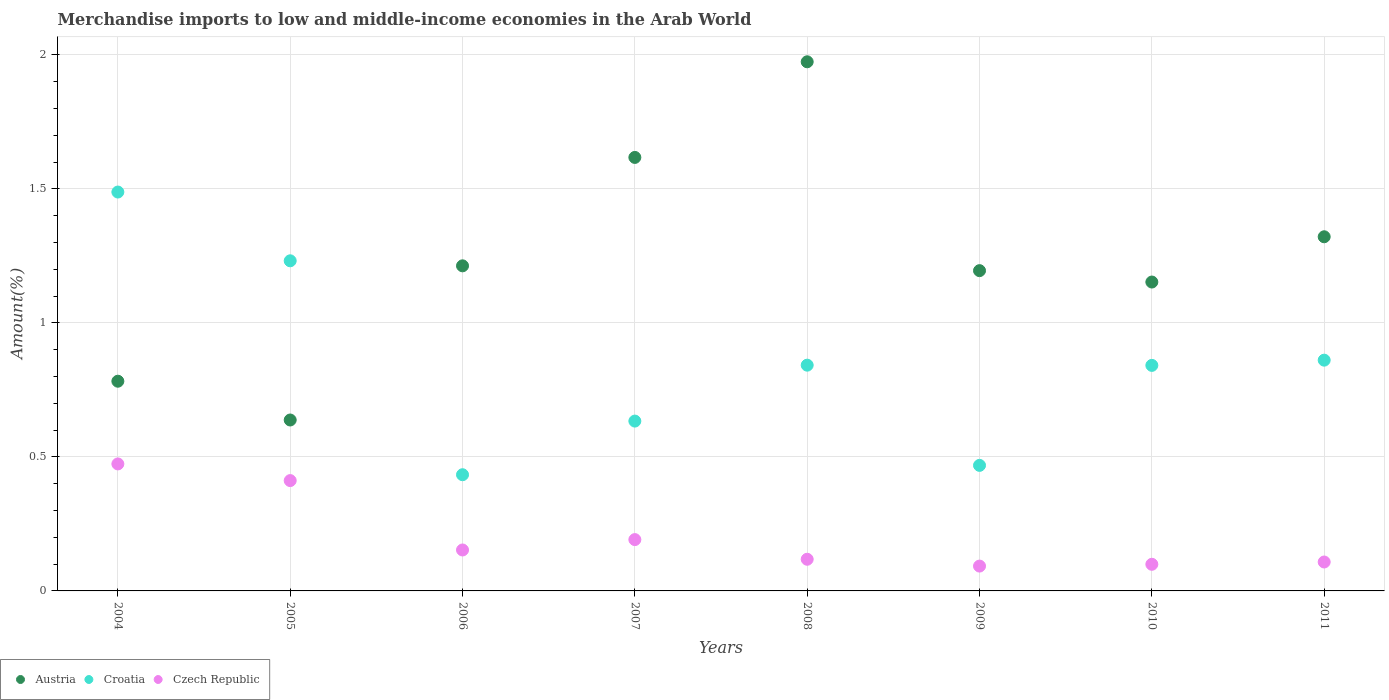How many different coloured dotlines are there?
Give a very brief answer. 3. What is the percentage of amount earned from merchandise imports in Czech Republic in 2004?
Provide a succinct answer. 0.47. Across all years, what is the maximum percentage of amount earned from merchandise imports in Croatia?
Ensure brevity in your answer.  1.49. Across all years, what is the minimum percentage of amount earned from merchandise imports in Austria?
Your answer should be very brief. 0.64. What is the total percentage of amount earned from merchandise imports in Austria in the graph?
Give a very brief answer. 9.89. What is the difference between the percentage of amount earned from merchandise imports in Austria in 2005 and that in 2006?
Provide a short and direct response. -0.58. What is the difference between the percentage of amount earned from merchandise imports in Croatia in 2004 and the percentage of amount earned from merchandise imports in Austria in 2010?
Make the answer very short. 0.34. What is the average percentage of amount earned from merchandise imports in Austria per year?
Give a very brief answer. 1.24. In the year 2011, what is the difference between the percentage of amount earned from merchandise imports in Czech Republic and percentage of amount earned from merchandise imports in Croatia?
Keep it short and to the point. -0.75. What is the ratio of the percentage of amount earned from merchandise imports in Czech Republic in 2009 to that in 2011?
Offer a terse response. 0.86. Is the percentage of amount earned from merchandise imports in Croatia in 2005 less than that in 2007?
Keep it short and to the point. No. What is the difference between the highest and the second highest percentage of amount earned from merchandise imports in Czech Republic?
Give a very brief answer. 0.06. What is the difference between the highest and the lowest percentage of amount earned from merchandise imports in Czech Republic?
Give a very brief answer. 0.38. Is it the case that in every year, the sum of the percentage of amount earned from merchandise imports in Croatia and percentage of amount earned from merchandise imports in Austria  is greater than the percentage of amount earned from merchandise imports in Czech Republic?
Provide a short and direct response. Yes. How many dotlines are there?
Keep it short and to the point. 3. How many years are there in the graph?
Offer a terse response. 8. What is the difference between two consecutive major ticks on the Y-axis?
Ensure brevity in your answer.  0.5. Does the graph contain grids?
Your response must be concise. Yes. How are the legend labels stacked?
Make the answer very short. Horizontal. What is the title of the graph?
Your response must be concise. Merchandise imports to low and middle-income economies in the Arab World. What is the label or title of the X-axis?
Keep it short and to the point. Years. What is the label or title of the Y-axis?
Offer a very short reply. Amount(%). What is the Amount(%) of Austria in 2004?
Offer a terse response. 0.78. What is the Amount(%) in Croatia in 2004?
Give a very brief answer. 1.49. What is the Amount(%) in Czech Republic in 2004?
Provide a short and direct response. 0.47. What is the Amount(%) of Austria in 2005?
Give a very brief answer. 0.64. What is the Amount(%) in Croatia in 2005?
Your response must be concise. 1.23. What is the Amount(%) of Czech Republic in 2005?
Provide a succinct answer. 0.41. What is the Amount(%) in Austria in 2006?
Provide a short and direct response. 1.21. What is the Amount(%) in Croatia in 2006?
Give a very brief answer. 0.43. What is the Amount(%) of Czech Republic in 2006?
Provide a succinct answer. 0.15. What is the Amount(%) of Austria in 2007?
Ensure brevity in your answer.  1.62. What is the Amount(%) of Croatia in 2007?
Ensure brevity in your answer.  0.63. What is the Amount(%) in Czech Republic in 2007?
Provide a short and direct response. 0.19. What is the Amount(%) of Austria in 2008?
Make the answer very short. 1.97. What is the Amount(%) of Croatia in 2008?
Give a very brief answer. 0.84. What is the Amount(%) of Czech Republic in 2008?
Your response must be concise. 0.12. What is the Amount(%) of Austria in 2009?
Give a very brief answer. 1.19. What is the Amount(%) in Croatia in 2009?
Your answer should be compact. 0.47. What is the Amount(%) of Czech Republic in 2009?
Keep it short and to the point. 0.09. What is the Amount(%) of Austria in 2010?
Give a very brief answer. 1.15. What is the Amount(%) in Croatia in 2010?
Your answer should be very brief. 0.84. What is the Amount(%) in Czech Republic in 2010?
Your response must be concise. 0.1. What is the Amount(%) of Austria in 2011?
Offer a terse response. 1.32. What is the Amount(%) in Croatia in 2011?
Your answer should be compact. 0.86. What is the Amount(%) of Czech Republic in 2011?
Offer a very short reply. 0.11. Across all years, what is the maximum Amount(%) of Austria?
Provide a succinct answer. 1.97. Across all years, what is the maximum Amount(%) of Croatia?
Provide a short and direct response. 1.49. Across all years, what is the maximum Amount(%) in Czech Republic?
Ensure brevity in your answer.  0.47. Across all years, what is the minimum Amount(%) in Austria?
Offer a terse response. 0.64. Across all years, what is the minimum Amount(%) in Croatia?
Provide a short and direct response. 0.43. Across all years, what is the minimum Amount(%) in Czech Republic?
Make the answer very short. 0.09. What is the total Amount(%) in Austria in the graph?
Give a very brief answer. 9.89. What is the total Amount(%) of Croatia in the graph?
Give a very brief answer. 6.8. What is the total Amount(%) of Czech Republic in the graph?
Provide a succinct answer. 1.65. What is the difference between the Amount(%) of Austria in 2004 and that in 2005?
Your answer should be very brief. 0.14. What is the difference between the Amount(%) of Croatia in 2004 and that in 2005?
Your response must be concise. 0.26. What is the difference between the Amount(%) in Czech Republic in 2004 and that in 2005?
Provide a succinct answer. 0.06. What is the difference between the Amount(%) in Austria in 2004 and that in 2006?
Your response must be concise. -0.43. What is the difference between the Amount(%) in Croatia in 2004 and that in 2006?
Give a very brief answer. 1.05. What is the difference between the Amount(%) in Czech Republic in 2004 and that in 2006?
Your response must be concise. 0.32. What is the difference between the Amount(%) of Austria in 2004 and that in 2007?
Ensure brevity in your answer.  -0.83. What is the difference between the Amount(%) in Croatia in 2004 and that in 2007?
Ensure brevity in your answer.  0.85. What is the difference between the Amount(%) in Czech Republic in 2004 and that in 2007?
Offer a terse response. 0.28. What is the difference between the Amount(%) in Austria in 2004 and that in 2008?
Keep it short and to the point. -1.19. What is the difference between the Amount(%) of Croatia in 2004 and that in 2008?
Offer a very short reply. 0.65. What is the difference between the Amount(%) in Czech Republic in 2004 and that in 2008?
Keep it short and to the point. 0.36. What is the difference between the Amount(%) in Austria in 2004 and that in 2009?
Make the answer very short. -0.41. What is the difference between the Amount(%) in Croatia in 2004 and that in 2009?
Your response must be concise. 1.02. What is the difference between the Amount(%) in Czech Republic in 2004 and that in 2009?
Offer a very short reply. 0.38. What is the difference between the Amount(%) of Austria in 2004 and that in 2010?
Provide a short and direct response. -0.37. What is the difference between the Amount(%) in Croatia in 2004 and that in 2010?
Provide a succinct answer. 0.65. What is the difference between the Amount(%) in Czech Republic in 2004 and that in 2010?
Offer a terse response. 0.37. What is the difference between the Amount(%) in Austria in 2004 and that in 2011?
Make the answer very short. -0.54. What is the difference between the Amount(%) of Croatia in 2004 and that in 2011?
Provide a succinct answer. 0.63. What is the difference between the Amount(%) in Czech Republic in 2004 and that in 2011?
Ensure brevity in your answer.  0.37. What is the difference between the Amount(%) in Austria in 2005 and that in 2006?
Ensure brevity in your answer.  -0.58. What is the difference between the Amount(%) in Croatia in 2005 and that in 2006?
Your response must be concise. 0.8. What is the difference between the Amount(%) in Czech Republic in 2005 and that in 2006?
Make the answer very short. 0.26. What is the difference between the Amount(%) of Austria in 2005 and that in 2007?
Offer a terse response. -0.98. What is the difference between the Amount(%) of Croatia in 2005 and that in 2007?
Offer a terse response. 0.6. What is the difference between the Amount(%) of Czech Republic in 2005 and that in 2007?
Provide a short and direct response. 0.22. What is the difference between the Amount(%) of Austria in 2005 and that in 2008?
Make the answer very short. -1.34. What is the difference between the Amount(%) of Croatia in 2005 and that in 2008?
Give a very brief answer. 0.39. What is the difference between the Amount(%) of Czech Republic in 2005 and that in 2008?
Offer a terse response. 0.29. What is the difference between the Amount(%) in Austria in 2005 and that in 2009?
Keep it short and to the point. -0.56. What is the difference between the Amount(%) of Croatia in 2005 and that in 2009?
Offer a very short reply. 0.76. What is the difference between the Amount(%) of Czech Republic in 2005 and that in 2009?
Your answer should be compact. 0.32. What is the difference between the Amount(%) of Austria in 2005 and that in 2010?
Provide a succinct answer. -0.51. What is the difference between the Amount(%) of Croatia in 2005 and that in 2010?
Provide a short and direct response. 0.39. What is the difference between the Amount(%) in Czech Republic in 2005 and that in 2010?
Ensure brevity in your answer.  0.31. What is the difference between the Amount(%) of Austria in 2005 and that in 2011?
Your answer should be compact. -0.68. What is the difference between the Amount(%) in Croatia in 2005 and that in 2011?
Offer a terse response. 0.37. What is the difference between the Amount(%) in Czech Republic in 2005 and that in 2011?
Offer a terse response. 0.3. What is the difference between the Amount(%) in Austria in 2006 and that in 2007?
Provide a short and direct response. -0.4. What is the difference between the Amount(%) of Croatia in 2006 and that in 2007?
Offer a very short reply. -0.2. What is the difference between the Amount(%) in Czech Republic in 2006 and that in 2007?
Keep it short and to the point. -0.04. What is the difference between the Amount(%) of Austria in 2006 and that in 2008?
Keep it short and to the point. -0.76. What is the difference between the Amount(%) in Croatia in 2006 and that in 2008?
Provide a short and direct response. -0.41. What is the difference between the Amount(%) of Czech Republic in 2006 and that in 2008?
Offer a very short reply. 0.03. What is the difference between the Amount(%) in Austria in 2006 and that in 2009?
Keep it short and to the point. 0.02. What is the difference between the Amount(%) of Croatia in 2006 and that in 2009?
Give a very brief answer. -0.03. What is the difference between the Amount(%) of Czech Republic in 2006 and that in 2009?
Your answer should be compact. 0.06. What is the difference between the Amount(%) of Austria in 2006 and that in 2010?
Make the answer very short. 0.06. What is the difference between the Amount(%) of Croatia in 2006 and that in 2010?
Offer a very short reply. -0.41. What is the difference between the Amount(%) in Czech Republic in 2006 and that in 2010?
Your answer should be very brief. 0.05. What is the difference between the Amount(%) of Austria in 2006 and that in 2011?
Offer a very short reply. -0.11. What is the difference between the Amount(%) of Croatia in 2006 and that in 2011?
Your answer should be very brief. -0.43. What is the difference between the Amount(%) in Czech Republic in 2006 and that in 2011?
Offer a terse response. 0.04. What is the difference between the Amount(%) of Austria in 2007 and that in 2008?
Offer a terse response. -0.36. What is the difference between the Amount(%) of Croatia in 2007 and that in 2008?
Provide a short and direct response. -0.21. What is the difference between the Amount(%) of Czech Republic in 2007 and that in 2008?
Make the answer very short. 0.07. What is the difference between the Amount(%) in Austria in 2007 and that in 2009?
Ensure brevity in your answer.  0.42. What is the difference between the Amount(%) of Croatia in 2007 and that in 2009?
Ensure brevity in your answer.  0.17. What is the difference between the Amount(%) in Czech Republic in 2007 and that in 2009?
Your answer should be very brief. 0.1. What is the difference between the Amount(%) in Austria in 2007 and that in 2010?
Make the answer very short. 0.46. What is the difference between the Amount(%) of Croatia in 2007 and that in 2010?
Ensure brevity in your answer.  -0.21. What is the difference between the Amount(%) of Czech Republic in 2007 and that in 2010?
Give a very brief answer. 0.09. What is the difference between the Amount(%) of Austria in 2007 and that in 2011?
Your answer should be very brief. 0.3. What is the difference between the Amount(%) in Croatia in 2007 and that in 2011?
Offer a terse response. -0.23. What is the difference between the Amount(%) in Czech Republic in 2007 and that in 2011?
Your answer should be very brief. 0.08. What is the difference between the Amount(%) in Austria in 2008 and that in 2009?
Keep it short and to the point. 0.78. What is the difference between the Amount(%) in Croatia in 2008 and that in 2009?
Provide a succinct answer. 0.37. What is the difference between the Amount(%) of Czech Republic in 2008 and that in 2009?
Provide a short and direct response. 0.03. What is the difference between the Amount(%) of Austria in 2008 and that in 2010?
Provide a short and direct response. 0.82. What is the difference between the Amount(%) in Croatia in 2008 and that in 2010?
Offer a very short reply. 0. What is the difference between the Amount(%) in Czech Republic in 2008 and that in 2010?
Provide a succinct answer. 0.02. What is the difference between the Amount(%) in Austria in 2008 and that in 2011?
Ensure brevity in your answer.  0.65. What is the difference between the Amount(%) of Croatia in 2008 and that in 2011?
Ensure brevity in your answer.  -0.02. What is the difference between the Amount(%) of Czech Republic in 2008 and that in 2011?
Provide a short and direct response. 0.01. What is the difference between the Amount(%) of Austria in 2009 and that in 2010?
Provide a succinct answer. 0.04. What is the difference between the Amount(%) of Croatia in 2009 and that in 2010?
Keep it short and to the point. -0.37. What is the difference between the Amount(%) of Czech Republic in 2009 and that in 2010?
Offer a very short reply. -0.01. What is the difference between the Amount(%) in Austria in 2009 and that in 2011?
Keep it short and to the point. -0.13. What is the difference between the Amount(%) of Croatia in 2009 and that in 2011?
Provide a short and direct response. -0.39. What is the difference between the Amount(%) in Czech Republic in 2009 and that in 2011?
Provide a succinct answer. -0.02. What is the difference between the Amount(%) in Austria in 2010 and that in 2011?
Provide a short and direct response. -0.17. What is the difference between the Amount(%) of Croatia in 2010 and that in 2011?
Give a very brief answer. -0.02. What is the difference between the Amount(%) of Czech Republic in 2010 and that in 2011?
Your response must be concise. -0.01. What is the difference between the Amount(%) in Austria in 2004 and the Amount(%) in Croatia in 2005?
Make the answer very short. -0.45. What is the difference between the Amount(%) of Austria in 2004 and the Amount(%) of Czech Republic in 2005?
Make the answer very short. 0.37. What is the difference between the Amount(%) of Croatia in 2004 and the Amount(%) of Czech Republic in 2005?
Offer a terse response. 1.08. What is the difference between the Amount(%) in Austria in 2004 and the Amount(%) in Croatia in 2006?
Your response must be concise. 0.35. What is the difference between the Amount(%) of Austria in 2004 and the Amount(%) of Czech Republic in 2006?
Make the answer very short. 0.63. What is the difference between the Amount(%) in Croatia in 2004 and the Amount(%) in Czech Republic in 2006?
Keep it short and to the point. 1.34. What is the difference between the Amount(%) of Austria in 2004 and the Amount(%) of Croatia in 2007?
Provide a succinct answer. 0.15. What is the difference between the Amount(%) in Austria in 2004 and the Amount(%) in Czech Republic in 2007?
Provide a short and direct response. 0.59. What is the difference between the Amount(%) in Croatia in 2004 and the Amount(%) in Czech Republic in 2007?
Offer a terse response. 1.3. What is the difference between the Amount(%) of Austria in 2004 and the Amount(%) of Croatia in 2008?
Your answer should be compact. -0.06. What is the difference between the Amount(%) in Austria in 2004 and the Amount(%) in Czech Republic in 2008?
Your answer should be very brief. 0.66. What is the difference between the Amount(%) of Croatia in 2004 and the Amount(%) of Czech Republic in 2008?
Make the answer very short. 1.37. What is the difference between the Amount(%) of Austria in 2004 and the Amount(%) of Croatia in 2009?
Keep it short and to the point. 0.31. What is the difference between the Amount(%) in Austria in 2004 and the Amount(%) in Czech Republic in 2009?
Your answer should be very brief. 0.69. What is the difference between the Amount(%) of Croatia in 2004 and the Amount(%) of Czech Republic in 2009?
Give a very brief answer. 1.4. What is the difference between the Amount(%) of Austria in 2004 and the Amount(%) of Croatia in 2010?
Your answer should be very brief. -0.06. What is the difference between the Amount(%) of Austria in 2004 and the Amount(%) of Czech Republic in 2010?
Your answer should be very brief. 0.68. What is the difference between the Amount(%) of Croatia in 2004 and the Amount(%) of Czech Republic in 2010?
Provide a succinct answer. 1.39. What is the difference between the Amount(%) of Austria in 2004 and the Amount(%) of Croatia in 2011?
Ensure brevity in your answer.  -0.08. What is the difference between the Amount(%) of Austria in 2004 and the Amount(%) of Czech Republic in 2011?
Ensure brevity in your answer.  0.67. What is the difference between the Amount(%) in Croatia in 2004 and the Amount(%) in Czech Republic in 2011?
Your answer should be very brief. 1.38. What is the difference between the Amount(%) of Austria in 2005 and the Amount(%) of Croatia in 2006?
Give a very brief answer. 0.2. What is the difference between the Amount(%) in Austria in 2005 and the Amount(%) in Czech Republic in 2006?
Your answer should be compact. 0.48. What is the difference between the Amount(%) in Croatia in 2005 and the Amount(%) in Czech Republic in 2006?
Your answer should be compact. 1.08. What is the difference between the Amount(%) in Austria in 2005 and the Amount(%) in Croatia in 2007?
Ensure brevity in your answer.  0. What is the difference between the Amount(%) in Austria in 2005 and the Amount(%) in Czech Republic in 2007?
Keep it short and to the point. 0.45. What is the difference between the Amount(%) in Croatia in 2005 and the Amount(%) in Czech Republic in 2007?
Your answer should be compact. 1.04. What is the difference between the Amount(%) in Austria in 2005 and the Amount(%) in Croatia in 2008?
Ensure brevity in your answer.  -0.2. What is the difference between the Amount(%) of Austria in 2005 and the Amount(%) of Czech Republic in 2008?
Make the answer very short. 0.52. What is the difference between the Amount(%) in Croatia in 2005 and the Amount(%) in Czech Republic in 2008?
Give a very brief answer. 1.11. What is the difference between the Amount(%) of Austria in 2005 and the Amount(%) of Croatia in 2009?
Provide a succinct answer. 0.17. What is the difference between the Amount(%) of Austria in 2005 and the Amount(%) of Czech Republic in 2009?
Offer a terse response. 0.55. What is the difference between the Amount(%) of Croatia in 2005 and the Amount(%) of Czech Republic in 2009?
Make the answer very short. 1.14. What is the difference between the Amount(%) of Austria in 2005 and the Amount(%) of Croatia in 2010?
Make the answer very short. -0.2. What is the difference between the Amount(%) of Austria in 2005 and the Amount(%) of Czech Republic in 2010?
Your answer should be very brief. 0.54. What is the difference between the Amount(%) of Croatia in 2005 and the Amount(%) of Czech Republic in 2010?
Make the answer very short. 1.13. What is the difference between the Amount(%) in Austria in 2005 and the Amount(%) in Croatia in 2011?
Your answer should be compact. -0.22. What is the difference between the Amount(%) in Austria in 2005 and the Amount(%) in Czech Republic in 2011?
Your answer should be compact. 0.53. What is the difference between the Amount(%) in Croatia in 2005 and the Amount(%) in Czech Republic in 2011?
Provide a short and direct response. 1.12. What is the difference between the Amount(%) of Austria in 2006 and the Amount(%) of Croatia in 2007?
Keep it short and to the point. 0.58. What is the difference between the Amount(%) of Austria in 2006 and the Amount(%) of Czech Republic in 2007?
Make the answer very short. 1.02. What is the difference between the Amount(%) of Croatia in 2006 and the Amount(%) of Czech Republic in 2007?
Provide a succinct answer. 0.24. What is the difference between the Amount(%) in Austria in 2006 and the Amount(%) in Croatia in 2008?
Offer a very short reply. 0.37. What is the difference between the Amount(%) of Austria in 2006 and the Amount(%) of Czech Republic in 2008?
Your answer should be very brief. 1.09. What is the difference between the Amount(%) in Croatia in 2006 and the Amount(%) in Czech Republic in 2008?
Offer a terse response. 0.32. What is the difference between the Amount(%) of Austria in 2006 and the Amount(%) of Croatia in 2009?
Make the answer very short. 0.74. What is the difference between the Amount(%) of Austria in 2006 and the Amount(%) of Czech Republic in 2009?
Give a very brief answer. 1.12. What is the difference between the Amount(%) of Croatia in 2006 and the Amount(%) of Czech Republic in 2009?
Offer a very short reply. 0.34. What is the difference between the Amount(%) in Austria in 2006 and the Amount(%) in Croatia in 2010?
Provide a short and direct response. 0.37. What is the difference between the Amount(%) of Austria in 2006 and the Amount(%) of Czech Republic in 2010?
Ensure brevity in your answer.  1.11. What is the difference between the Amount(%) of Croatia in 2006 and the Amount(%) of Czech Republic in 2010?
Ensure brevity in your answer.  0.33. What is the difference between the Amount(%) of Austria in 2006 and the Amount(%) of Croatia in 2011?
Make the answer very short. 0.35. What is the difference between the Amount(%) in Austria in 2006 and the Amount(%) in Czech Republic in 2011?
Offer a terse response. 1.1. What is the difference between the Amount(%) of Croatia in 2006 and the Amount(%) of Czech Republic in 2011?
Provide a succinct answer. 0.33. What is the difference between the Amount(%) of Austria in 2007 and the Amount(%) of Croatia in 2008?
Give a very brief answer. 0.78. What is the difference between the Amount(%) of Austria in 2007 and the Amount(%) of Czech Republic in 2008?
Your answer should be compact. 1.5. What is the difference between the Amount(%) in Croatia in 2007 and the Amount(%) in Czech Republic in 2008?
Offer a terse response. 0.52. What is the difference between the Amount(%) in Austria in 2007 and the Amount(%) in Croatia in 2009?
Give a very brief answer. 1.15. What is the difference between the Amount(%) in Austria in 2007 and the Amount(%) in Czech Republic in 2009?
Your response must be concise. 1.52. What is the difference between the Amount(%) of Croatia in 2007 and the Amount(%) of Czech Republic in 2009?
Your answer should be compact. 0.54. What is the difference between the Amount(%) in Austria in 2007 and the Amount(%) in Croatia in 2010?
Provide a succinct answer. 0.78. What is the difference between the Amount(%) in Austria in 2007 and the Amount(%) in Czech Republic in 2010?
Offer a very short reply. 1.52. What is the difference between the Amount(%) of Croatia in 2007 and the Amount(%) of Czech Republic in 2010?
Give a very brief answer. 0.53. What is the difference between the Amount(%) in Austria in 2007 and the Amount(%) in Croatia in 2011?
Give a very brief answer. 0.76. What is the difference between the Amount(%) in Austria in 2007 and the Amount(%) in Czech Republic in 2011?
Your response must be concise. 1.51. What is the difference between the Amount(%) in Croatia in 2007 and the Amount(%) in Czech Republic in 2011?
Provide a short and direct response. 0.53. What is the difference between the Amount(%) in Austria in 2008 and the Amount(%) in Croatia in 2009?
Make the answer very short. 1.51. What is the difference between the Amount(%) of Austria in 2008 and the Amount(%) of Czech Republic in 2009?
Offer a terse response. 1.88. What is the difference between the Amount(%) of Croatia in 2008 and the Amount(%) of Czech Republic in 2009?
Keep it short and to the point. 0.75. What is the difference between the Amount(%) of Austria in 2008 and the Amount(%) of Croatia in 2010?
Your answer should be very brief. 1.13. What is the difference between the Amount(%) in Austria in 2008 and the Amount(%) in Czech Republic in 2010?
Ensure brevity in your answer.  1.87. What is the difference between the Amount(%) in Croatia in 2008 and the Amount(%) in Czech Republic in 2010?
Give a very brief answer. 0.74. What is the difference between the Amount(%) in Austria in 2008 and the Amount(%) in Croatia in 2011?
Make the answer very short. 1.11. What is the difference between the Amount(%) of Austria in 2008 and the Amount(%) of Czech Republic in 2011?
Provide a short and direct response. 1.87. What is the difference between the Amount(%) of Croatia in 2008 and the Amount(%) of Czech Republic in 2011?
Offer a terse response. 0.73. What is the difference between the Amount(%) of Austria in 2009 and the Amount(%) of Croatia in 2010?
Give a very brief answer. 0.35. What is the difference between the Amount(%) in Austria in 2009 and the Amount(%) in Czech Republic in 2010?
Your answer should be compact. 1.1. What is the difference between the Amount(%) of Croatia in 2009 and the Amount(%) of Czech Republic in 2010?
Your answer should be very brief. 0.37. What is the difference between the Amount(%) of Austria in 2009 and the Amount(%) of Croatia in 2011?
Provide a short and direct response. 0.33. What is the difference between the Amount(%) in Austria in 2009 and the Amount(%) in Czech Republic in 2011?
Offer a very short reply. 1.09. What is the difference between the Amount(%) in Croatia in 2009 and the Amount(%) in Czech Republic in 2011?
Offer a very short reply. 0.36. What is the difference between the Amount(%) in Austria in 2010 and the Amount(%) in Croatia in 2011?
Your answer should be very brief. 0.29. What is the difference between the Amount(%) of Austria in 2010 and the Amount(%) of Czech Republic in 2011?
Keep it short and to the point. 1.04. What is the difference between the Amount(%) of Croatia in 2010 and the Amount(%) of Czech Republic in 2011?
Offer a very short reply. 0.73. What is the average Amount(%) in Austria per year?
Offer a terse response. 1.24. What is the average Amount(%) of Croatia per year?
Give a very brief answer. 0.85. What is the average Amount(%) in Czech Republic per year?
Keep it short and to the point. 0.21. In the year 2004, what is the difference between the Amount(%) in Austria and Amount(%) in Croatia?
Your answer should be compact. -0.71. In the year 2004, what is the difference between the Amount(%) of Austria and Amount(%) of Czech Republic?
Your response must be concise. 0.31. In the year 2004, what is the difference between the Amount(%) in Croatia and Amount(%) in Czech Republic?
Provide a short and direct response. 1.01. In the year 2005, what is the difference between the Amount(%) of Austria and Amount(%) of Croatia?
Keep it short and to the point. -0.59. In the year 2005, what is the difference between the Amount(%) in Austria and Amount(%) in Czech Republic?
Offer a very short reply. 0.23. In the year 2005, what is the difference between the Amount(%) of Croatia and Amount(%) of Czech Republic?
Your answer should be very brief. 0.82. In the year 2006, what is the difference between the Amount(%) of Austria and Amount(%) of Croatia?
Ensure brevity in your answer.  0.78. In the year 2006, what is the difference between the Amount(%) in Austria and Amount(%) in Czech Republic?
Provide a succinct answer. 1.06. In the year 2006, what is the difference between the Amount(%) of Croatia and Amount(%) of Czech Republic?
Provide a short and direct response. 0.28. In the year 2007, what is the difference between the Amount(%) of Austria and Amount(%) of Croatia?
Give a very brief answer. 0.98. In the year 2007, what is the difference between the Amount(%) in Austria and Amount(%) in Czech Republic?
Offer a very short reply. 1.43. In the year 2007, what is the difference between the Amount(%) in Croatia and Amount(%) in Czech Republic?
Provide a succinct answer. 0.44. In the year 2008, what is the difference between the Amount(%) in Austria and Amount(%) in Croatia?
Ensure brevity in your answer.  1.13. In the year 2008, what is the difference between the Amount(%) in Austria and Amount(%) in Czech Republic?
Offer a terse response. 1.86. In the year 2008, what is the difference between the Amount(%) of Croatia and Amount(%) of Czech Republic?
Ensure brevity in your answer.  0.72. In the year 2009, what is the difference between the Amount(%) in Austria and Amount(%) in Croatia?
Make the answer very short. 0.73. In the year 2009, what is the difference between the Amount(%) of Austria and Amount(%) of Czech Republic?
Offer a terse response. 1.1. In the year 2009, what is the difference between the Amount(%) of Croatia and Amount(%) of Czech Republic?
Provide a short and direct response. 0.38. In the year 2010, what is the difference between the Amount(%) in Austria and Amount(%) in Croatia?
Give a very brief answer. 0.31. In the year 2010, what is the difference between the Amount(%) of Austria and Amount(%) of Czech Republic?
Provide a short and direct response. 1.05. In the year 2010, what is the difference between the Amount(%) in Croatia and Amount(%) in Czech Republic?
Provide a short and direct response. 0.74. In the year 2011, what is the difference between the Amount(%) of Austria and Amount(%) of Croatia?
Give a very brief answer. 0.46. In the year 2011, what is the difference between the Amount(%) in Austria and Amount(%) in Czech Republic?
Ensure brevity in your answer.  1.21. In the year 2011, what is the difference between the Amount(%) of Croatia and Amount(%) of Czech Republic?
Provide a succinct answer. 0.75. What is the ratio of the Amount(%) of Austria in 2004 to that in 2005?
Keep it short and to the point. 1.23. What is the ratio of the Amount(%) in Croatia in 2004 to that in 2005?
Offer a terse response. 1.21. What is the ratio of the Amount(%) in Czech Republic in 2004 to that in 2005?
Provide a succinct answer. 1.15. What is the ratio of the Amount(%) of Austria in 2004 to that in 2006?
Ensure brevity in your answer.  0.65. What is the ratio of the Amount(%) in Croatia in 2004 to that in 2006?
Keep it short and to the point. 3.43. What is the ratio of the Amount(%) of Czech Republic in 2004 to that in 2006?
Your answer should be very brief. 3.1. What is the ratio of the Amount(%) of Austria in 2004 to that in 2007?
Provide a succinct answer. 0.48. What is the ratio of the Amount(%) of Croatia in 2004 to that in 2007?
Keep it short and to the point. 2.35. What is the ratio of the Amount(%) of Czech Republic in 2004 to that in 2007?
Ensure brevity in your answer.  2.47. What is the ratio of the Amount(%) of Austria in 2004 to that in 2008?
Offer a terse response. 0.4. What is the ratio of the Amount(%) of Croatia in 2004 to that in 2008?
Offer a very short reply. 1.77. What is the ratio of the Amount(%) of Czech Republic in 2004 to that in 2008?
Make the answer very short. 4.01. What is the ratio of the Amount(%) of Austria in 2004 to that in 2009?
Keep it short and to the point. 0.65. What is the ratio of the Amount(%) of Croatia in 2004 to that in 2009?
Keep it short and to the point. 3.18. What is the ratio of the Amount(%) in Czech Republic in 2004 to that in 2009?
Provide a succinct answer. 5.11. What is the ratio of the Amount(%) of Austria in 2004 to that in 2010?
Provide a succinct answer. 0.68. What is the ratio of the Amount(%) in Croatia in 2004 to that in 2010?
Your answer should be very brief. 1.77. What is the ratio of the Amount(%) of Czech Republic in 2004 to that in 2010?
Your answer should be very brief. 4.77. What is the ratio of the Amount(%) in Austria in 2004 to that in 2011?
Give a very brief answer. 0.59. What is the ratio of the Amount(%) of Croatia in 2004 to that in 2011?
Offer a very short reply. 1.73. What is the ratio of the Amount(%) in Czech Republic in 2004 to that in 2011?
Make the answer very short. 4.39. What is the ratio of the Amount(%) of Austria in 2005 to that in 2006?
Your answer should be compact. 0.53. What is the ratio of the Amount(%) of Croatia in 2005 to that in 2006?
Offer a very short reply. 2.84. What is the ratio of the Amount(%) of Czech Republic in 2005 to that in 2006?
Ensure brevity in your answer.  2.69. What is the ratio of the Amount(%) in Austria in 2005 to that in 2007?
Offer a terse response. 0.39. What is the ratio of the Amount(%) in Croatia in 2005 to that in 2007?
Give a very brief answer. 1.94. What is the ratio of the Amount(%) of Czech Republic in 2005 to that in 2007?
Provide a short and direct response. 2.15. What is the ratio of the Amount(%) in Austria in 2005 to that in 2008?
Your answer should be very brief. 0.32. What is the ratio of the Amount(%) of Croatia in 2005 to that in 2008?
Offer a very short reply. 1.46. What is the ratio of the Amount(%) of Czech Republic in 2005 to that in 2008?
Give a very brief answer. 3.49. What is the ratio of the Amount(%) in Austria in 2005 to that in 2009?
Make the answer very short. 0.53. What is the ratio of the Amount(%) in Croatia in 2005 to that in 2009?
Keep it short and to the point. 2.63. What is the ratio of the Amount(%) of Czech Republic in 2005 to that in 2009?
Make the answer very short. 4.44. What is the ratio of the Amount(%) of Austria in 2005 to that in 2010?
Your answer should be very brief. 0.55. What is the ratio of the Amount(%) in Croatia in 2005 to that in 2010?
Provide a short and direct response. 1.46. What is the ratio of the Amount(%) of Czech Republic in 2005 to that in 2010?
Provide a short and direct response. 4.14. What is the ratio of the Amount(%) of Austria in 2005 to that in 2011?
Offer a very short reply. 0.48. What is the ratio of the Amount(%) of Croatia in 2005 to that in 2011?
Keep it short and to the point. 1.43. What is the ratio of the Amount(%) in Czech Republic in 2005 to that in 2011?
Offer a very short reply. 3.81. What is the ratio of the Amount(%) in Austria in 2006 to that in 2007?
Make the answer very short. 0.75. What is the ratio of the Amount(%) of Croatia in 2006 to that in 2007?
Keep it short and to the point. 0.68. What is the ratio of the Amount(%) in Czech Republic in 2006 to that in 2007?
Offer a terse response. 0.8. What is the ratio of the Amount(%) of Austria in 2006 to that in 2008?
Your answer should be compact. 0.61. What is the ratio of the Amount(%) in Croatia in 2006 to that in 2008?
Ensure brevity in your answer.  0.51. What is the ratio of the Amount(%) of Czech Republic in 2006 to that in 2008?
Offer a terse response. 1.29. What is the ratio of the Amount(%) of Austria in 2006 to that in 2009?
Your answer should be compact. 1.01. What is the ratio of the Amount(%) in Croatia in 2006 to that in 2009?
Offer a very short reply. 0.93. What is the ratio of the Amount(%) in Czech Republic in 2006 to that in 2009?
Keep it short and to the point. 1.65. What is the ratio of the Amount(%) in Austria in 2006 to that in 2010?
Provide a succinct answer. 1.05. What is the ratio of the Amount(%) in Croatia in 2006 to that in 2010?
Provide a succinct answer. 0.52. What is the ratio of the Amount(%) in Czech Republic in 2006 to that in 2010?
Provide a succinct answer. 1.54. What is the ratio of the Amount(%) of Austria in 2006 to that in 2011?
Your answer should be very brief. 0.92. What is the ratio of the Amount(%) of Croatia in 2006 to that in 2011?
Make the answer very short. 0.5. What is the ratio of the Amount(%) in Czech Republic in 2006 to that in 2011?
Keep it short and to the point. 1.42. What is the ratio of the Amount(%) of Austria in 2007 to that in 2008?
Ensure brevity in your answer.  0.82. What is the ratio of the Amount(%) of Croatia in 2007 to that in 2008?
Provide a succinct answer. 0.75. What is the ratio of the Amount(%) in Czech Republic in 2007 to that in 2008?
Offer a very short reply. 1.62. What is the ratio of the Amount(%) of Austria in 2007 to that in 2009?
Your response must be concise. 1.35. What is the ratio of the Amount(%) of Croatia in 2007 to that in 2009?
Your answer should be very brief. 1.35. What is the ratio of the Amount(%) in Czech Republic in 2007 to that in 2009?
Give a very brief answer. 2.07. What is the ratio of the Amount(%) of Austria in 2007 to that in 2010?
Your answer should be very brief. 1.4. What is the ratio of the Amount(%) of Croatia in 2007 to that in 2010?
Provide a succinct answer. 0.75. What is the ratio of the Amount(%) of Czech Republic in 2007 to that in 2010?
Your response must be concise. 1.93. What is the ratio of the Amount(%) in Austria in 2007 to that in 2011?
Your answer should be very brief. 1.22. What is the ratio of the Amount(%) of Croatia in 2007 to that in 2011?
Offer a terse response. 0.74. What is the ratio of the Amount(%) in Czech Republic in 2007 to that in 2011?
Your answer should be very brief. 1.77. What is the ratio of the Amount(%) in Austria in 2008 to that in 2009?
Give a very brief answer. 1.65. What is the ratio of the Amount(%) of Croatia in 2008 to that in 2009?
Your answer should be very brief. 1.8. What is the ratio of the Amount(%) in Czech Republic in 2008 to that in 2009?
Make the answer very short. 1.27. What is the ratio of the Amount(%) of Austria in 2008 to that in 2010?
Offer a terse response. 1.71. What is the ratio of the Amount(%) of Czech Republic in 2008 to that in 2010?
Your answer should be very brief. 1.19. What is the ratio of the Amount(%) of Austria in 2008 to that in 2011?
Make the answer very short. 1.49. What is the ratio of the Amount(%) of Croatia in 2008 to that in 2011?
Your answer should be very brief. 0.98. What is the ratio of the Amount(%) of Czech Republic in 2008 to that in 2011?
Offer a terse response. 1.09. What is the ratio of the Amount(%) of Austria in 2009 to that in 2010?
Your answer should be very brief. 1.04. What is the ratio of the Amount(%) of Croatia in 2009 to that in 2010?
Your answer should be compact. 0.56. What is the ratio of the Amount(%) of Czech Republic in 2009 to that in 2010?
Offer a very short reply. 0.93. What is the ratio of the Amount(%) in Austria in 2009 to that in 2011?
Ensure brevity in your answer.  0.9. What is the ratio of the Amount(%) of Croatia in 2009 to that in 2011?
Offer a terse response. 0.54. What is the ratio of the Amount(%) of Czech Republic in 2009 to that in 2011?
Make the answer very short. 0.86. What is the ratio of the Amount(%) of Austria in 2010 to that in 2011?
Make the answer very short. 0.87. What is the ratio of the Amount(%) in Croatia in 2010 to that in 2011?
Make the answer very short. 0.98. What is the ratio of the Amount(%) of Czech Republic in 2010 to that in 2011?
Your answer should be very brief. 0.92. What is the difference between the highest and the second highest Amount(%) of Austria?
Your answer should be very brief. 0.36. What is the difference between the highest and the second highest Amount(%) of Croatia?
Your response must be concise. 0.26. What is the difference between the highest and the second highest Amount(%) in Czech Republic?
Your response must be concise. 0.06. What is the difference between the highest and the lowest Amount(%) of Austria?
Provide a short and direct response. 1.34. What is the difference between the highest and the lowest Amount(%) of Croatia?
Your response must be concise. 1.05. What is the difference between the highest and the lowest Amount(%) in Czech Republic?
Make the answer very short. 0.38. 